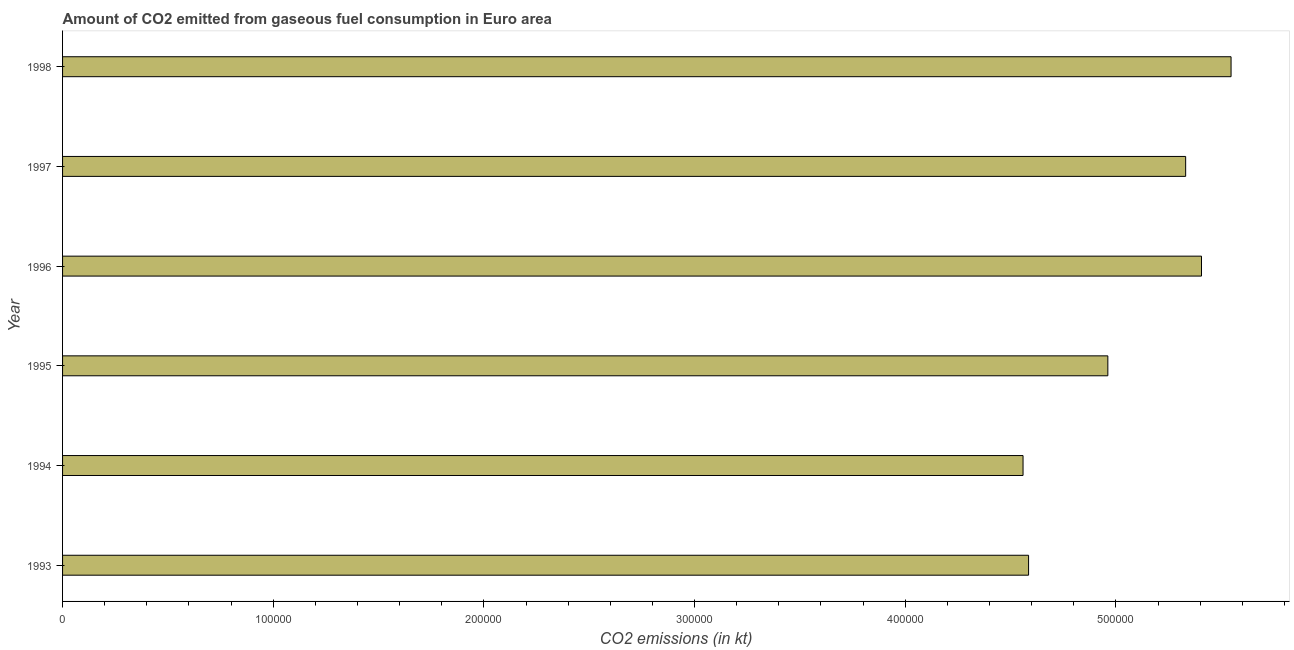Does the graph contain any zero values?
Your response must be concise. No. Does the graph contain grids?
Provide a short and direct response. No. What is the title of the graph?
Provide a short and direct response. Amount of CO2 emitted from gaseous fuel consumption in Euro area. What is the label or title of the X-axis?
Your answer should be very brief. CO2 emissions (in kt). What is the label or title of the Y-axis?
Keep it short and to the point. Year. What is the co2 emissions from gaseous fuel consumption in 1993?
Your answer should be compact. 4.59e+05. Across all years, what is the maximum co2 emissions from gaseous fuel consumption?
Give a very brief answer. 5.55e+05. Across all years, what is the minimum co2 emissions from gaseous fuel consumption?
Provide a short and direct response. 4.56e+05. In which year was the co2 emissions from gaseous fuel consumption maximum?
Give a very brief answer. 1998. In which year was the co2 emissions from gaseous fuel consumption minimum?
Provide a succinct answer. 1994. What is the sum of the co2 emissions from gaseous fuel consumption?
Provide a short and direct response. 3.04e+06. What is the difference between the co2 emissions from gaseous fuel consumption in 1997 and 1998?
Give a very brief answer. -2.16e+04. What is the average co2 emissions from gaseous fuel consumption per year?
Ensure brevity in your answer.  5.06e+05. What is the median co2 emissions from gaseous fuel consumption?
Offer a terse response. 5.15e+05. What is the ratio of the co2 emissions from gaseous fuel consumption in 1994 to that in 1995?
Your answer should be compact. 0.92. Is the co2 emissions from gaseous fuel consumption in 1996 less than that in 1998?
Your answer should be very brief. Yes. Is the difference between the co2 emissions from gaseous fuel consumption in 1997 and 1998 greater than the difference between any two years?
Give a very brief answer. No. What is the difference between the highest and the second highest co2 emissions from gaseous fuel consumption?
Give a very brief answer. 1.40e+04. What is the difference between the highest and the lowest co2 emissions from gaseous fuel consumption?
Your response must be concise. 9.87e+04. How many bars are there?
Offer a very short reply. 6. Are all the bars in the graph horizontal?
Ensure brevity in your answer.  Yes. How many years are there in the graph?
Keep it short and to the point. 6. Are the values on the major ticks of X-axis written in scientific E-notation?
Give a very brief answer. No. What is the CO2 emissions (in kt) in 1993?
Provide a succinct answer. 4.59e+05. What is the CO2 emissions (in kt) in 1994?
Give a very brief answer. 4.56e+05. What is the CO2 emissions (in kt) in 1995?
Ensure brevity in your answer.  4.96e+05. What is the CO2 emissions (in kt) of 1996?
Offer a terse response. 5.41e+05. What is the CO2 emissions (in kt) of 1997?
Offer a very short reply. 5.33e+05. What is the CO2 emissions (in kt) of 1998?
Make the answer very short. 5.55e+05. What is the difference between the CO2 emissions (in kt) in 1993 and 1994?
Give a very brief answer. 2624.82. What is the difference between the CO2 emissions (in kt) in 1993 and 1995?
Your response must be concise. -3.76e+04. What is the difference between the CO2 emissions (in kt) in 1993 and 1996?
Offer a very short reply. -8.21e+04. What is the difference between the CO2 emissions (in kt) in 1993 and 1997?
Make the answer very short. -7.46e+04. What is the difference between the CO2 emissions (in kt) in 1993 and 1998?
Give a very brief answer. -9.61e+04. What is the difference between the CO2 emissions (in kt) in 1994 and 1995?
Offer a very short reply. -4.03e+04. What is the difference between the CO2 emissions (in kt) in 1994 and 1996?
Provide a short and direct response. -8.47e+04. What is the difference between the CO2 emissions (in kt) in 1994 and 1997?
Offer a very short reply. -7.72e+04. What is the difference between the CO2 emissions (in kt) in 1994 and 1998?
Provide a succinct answer. -9.87e+04. What is the difference between the CO2 emissions (in kt) in 1995 and 1996?
Your answer should be compact. -4.45e+04. What is the difference between the CO2 emissions (in kt) in 1995 and 1997?
Give a very brief answer. -3.69e+04. What is the difference between the CO2 emissions (in kt) in 1995 and 1998?
Offer a very short reply. -5.85e+04. What is the difference between the CO2 emissions (in kt) in 1996 and 1997?
Ensure brevity in your answer.  7521.55. What is the difference between the CO2 emissions (in kt) in 1996 and 1998?
Your response must be concise. -1.40e+04. What is the difference between the CO2 emissions (in kt) in 1997 and 1998?
Offer a terse response. -2.16e+04. What is the ratio of the CO2 emissions (in kt) in 1993 to that in 1995?
Give a very brief answer. 0.92. What is the ratio of the CO2 emissions (in kt) in 1993 to that in 1996?
Keep it short and to the point. 0.85. What is the ratio of the CO2 emissions (in kt) in 1993 to that in 1997?
Ensure brevity in your answer.  0.86. What is the ratio of the CO2 emissions (in kt) in 1993 to that in 1998?
Ensure brevity in your answer.  0.83. What is the ratio of the CO2 emissions (in kt) in 1994 to that in 1995?
Offer a very short reply. 0.92. What is the ratio of the CO2 emissions (in kt) in 1994 to that in 1996?
Your answer should be very brief. 0.84. What is the ratio of the CO2 emissions (in kt) in 1994 to that in 1997?
Offer a very short reply. 0.85. What is the ratio of the CO2 emissions (in kt) in 1994 to that in 1998?
Your answer should be very brief. 0.82. What is the ratio of the CO2 emissions (in kt) in 1995 to that in 1996?
Your response must be concise. 0.92. What is the ratio of the CO2 emissions (in kt) in 1995 to that in 1997?
Your response must be concise. 0.93. What is the ratio of the CO2 emissions (in kt) in 1995 to that in 1998?
Provide a short and direct response. 0.9. What is the ratio of the CO2 emissions (in kt) in 1997 to that in 1998?
Make the answer very short. 0.96. 